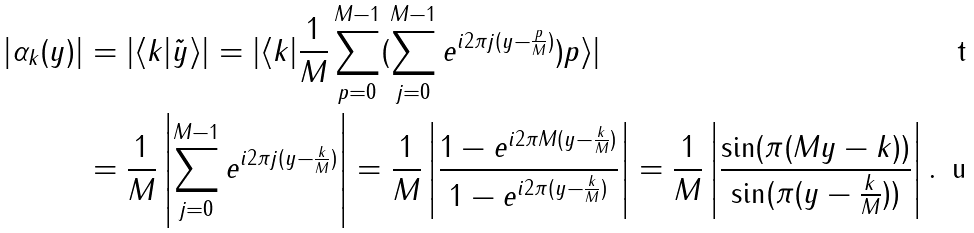Convert formula to latex. <formula><loc_0><loc_0><loc_500><loc_500>| \alpha _ { k } ( y ) | & = | \langle k | \tilde { y } \rangle | = | \langle k | \frac { 1 } { M } \sum _ { p = 0 } ^ { M - 1 } ( \sum _ { j = 0 } ^ { M - 1 } e ^ { i 2 \pi j ( y - \frac { p } { M } ) } ) p \rangle | \\ & = \frac { 1 } { M } \left | \sum _ { j = 0 } ^ { M - 1 } e ^ { i 2 \pi j ( y - \frac { k } { M } ) } \right | = \frac { 1 } { M } \left | \frac { 1 - e ^ { i 2 \pi M ( y - \frac { k } { M } ) } } { 1 - e ^ { i 2 \pi ( y - \frac { k } { M } ) } } \right | = \frac { 1 } { M } \left | \frac { \sin ( \pi ( M y - k ) ) } { \sin ( \pi ( y - \frac { k } { M } ) ) } \right | .</formula> 